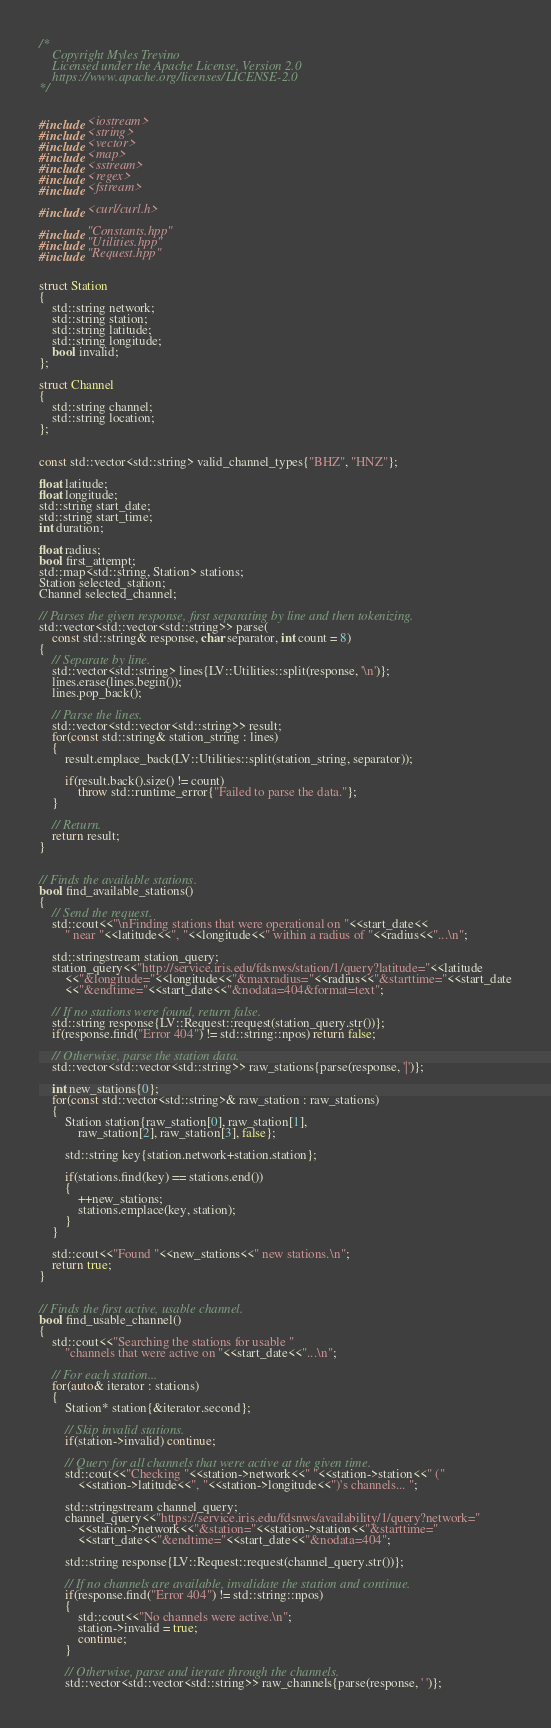Convert code to text. <code><loc_0><loc_0><loc_500><loc_500><_C++_>/*
	Copyright Myles Trevino
	Licensed under the Apache License, Version 2.0
	https://www.apache.org/licenses/LICENSE-2.0
*/


#include <iostream>
#include <string>
#include <vector>
#include <map>
#include <sstream>
#include <regex>
#include <fstream>

#include <curl/curl.h>

#include "Constants.hpp"
#include "Utilities.hpp"
#include "Request.hpp"


struct Station
{
	std::string network;
	std::string station;
	std::string latitude;
	std::string longitude;
	bool invalid;
};

struct Channel
{
	std::string channel;
	std::string location;
};


const std::vector<std::string> valid_channel_types{"BHZ", "HNZ"};

float latitude;
float longitude;
std::string start_date;
std::string start_time;
int duration;

float radius;
bool first_attempt;
std::map<std::string, Station> stations;
Station selected_station;
Channel selected_channel;

// Parses the given response, first separating by line and then tokenizing.
std::vector<std::vector<std::string>> parse(
	const std::string& response, char separator, int count = 8)
{
	// Separate by line.
	std::vector<std::string> lines{LV::Utilities::split(response, '\n')};
	lines.erase(lines.begin());
	lines.pop_back();

	// Parse the lines.
	std::vector<std::vector<std::string>> result;
	for(const std::string& station_string : lines)
	{
		result.emplace_back(LV::Utilities::split(station_string, separator));

		if(result.back().size() != count)
			throw std::runtime_error{"Failed to parse the data."};
	}

	// Return.
	return result;
}


// Finds the available stations.
bool find_available_stations()
{
	// Send the request.
	std::cout<<"\nFinding stations that were operational on "<<start_date<<
		" near "<<latitude<<", "<<longitude<<" within a radius of "<<radius<<"...\n";

	std::stringstream station_query;
	station_query<<"http://service.iris.edu/fdsnws/station/1/query?latitude="<<latitude
		<<"&longitude="<<longitude<<"&maxradius="<<radius<<"&starttime="<<start_date
		<<"&endtime="<<start_date<<"&nodata=404&format=text";

	// If no stations were found, return false.
	std::string response{LV::Request::request(station_query.str())};
	if(response.find("Error 404") != std::string::npos) return false;

	// Otherwise, parse the station data.
	std::vector<std::vector<std::string>> raw_stations{parse(response, '|')};

	int new_stations{0};
	for(const std::vector<std::string>& raw_station : raw_stations)
	{
		Station station{raw_station[0], raw_station[1],
			raw_station[2], raw_station[3], false};

		std::string key{station.network+station.station};

		if(stations.find(key) == stations.end())
		{
			++new_stations;
			stations.emplace(key, station);
		}
	}

	std::cout<<"Found "<<new_stations<<" new stations.\n";
	return true;
}


// Finds the first active, usable channel.
bool find_usable_channel()
{
	std::cout<<"Searching the stations for usable "
		"channels that were active on "<<start_date<<"...\n";

	// For each station...
	for(auto& iterator : stations)
	{
		Station* station{&iterator.second};

		// Skip invalid stations.
		if(station->invalid) continue;

		// Query for all channels that were active at the given time.
		std::cout<<"Checking "<<station->network<<" "<<station->station<<" ("
			<<station->latitude<<", "<<station->longitude<<")'s channels... ";

		std::stringstream channel_query;
		channel_query<<"https://service.iris.edu/fdsnws/availability/1/query?network="
			<<station->network<<"&station="<<station->station<<"&starttime="
			<<start_date<<"&endtime="<<start_date<<"&nodata=404";

		std::string response{LV::Request::request(channel_query.str())};

		// If no channels are available, invalidate the station and continue.
		if(response.find("Error 404") != std::string::npos)
		{
			std::cout<<"No channels were active.\n";
			station->invalid = true;
			continue;
		}

		// Otherwise, parse and iterate through the channels.
		std::vector<std::vector<std::string>> raw_channels{parse(response, ' ')};
</code> 